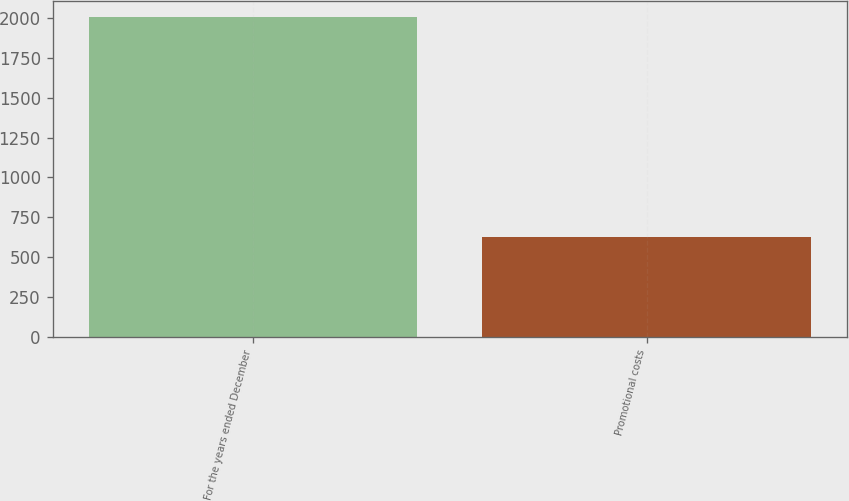<chart> <loc_0><loc_0><loc_500><loc_500><bar_chart><fcel>For the years ended December<fcel>Promotional costs<nl><fcel>2006<fcel>625.8<nl></chart> 